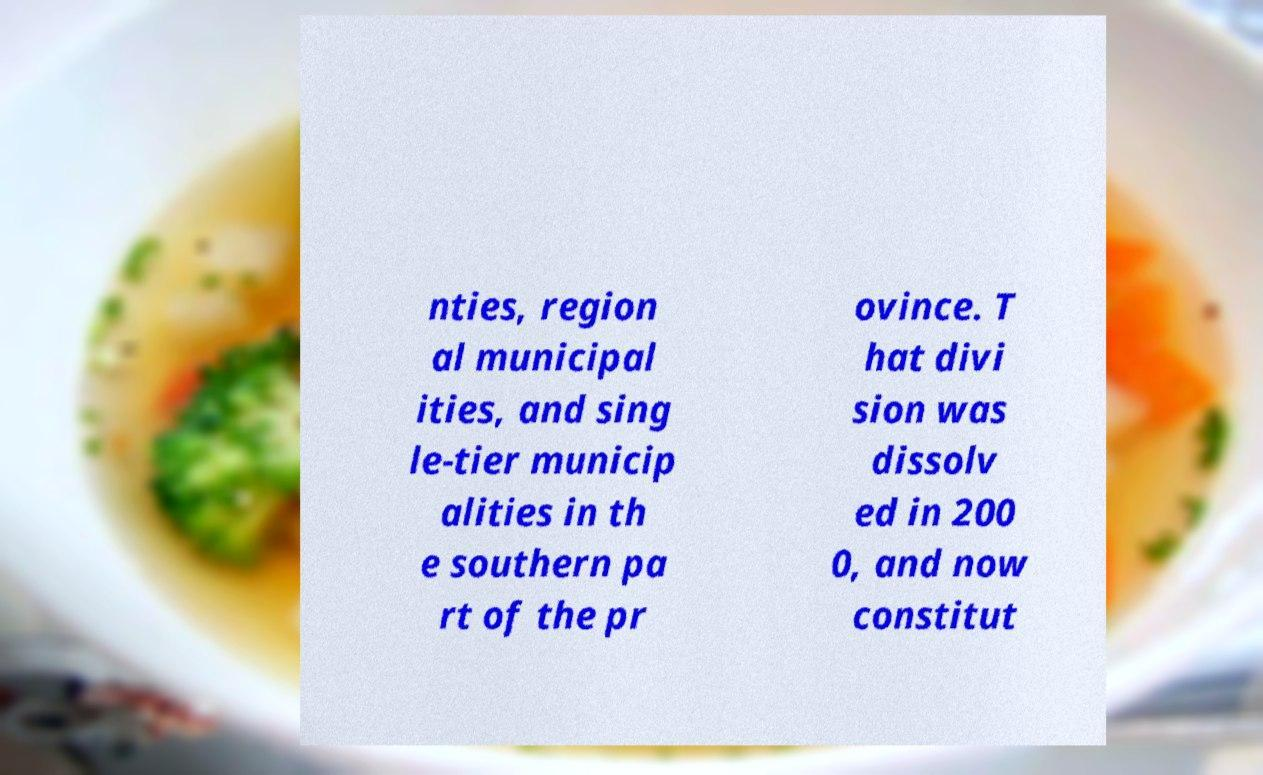Could you assist in decoding the text presented in this image and type it out clearly? nties, region al municipal ities, and sing le-tier municip alities in th e southern pa rt of the pr ovince. T hat divi sion was dissolv ed in 200 0, and now constitut 